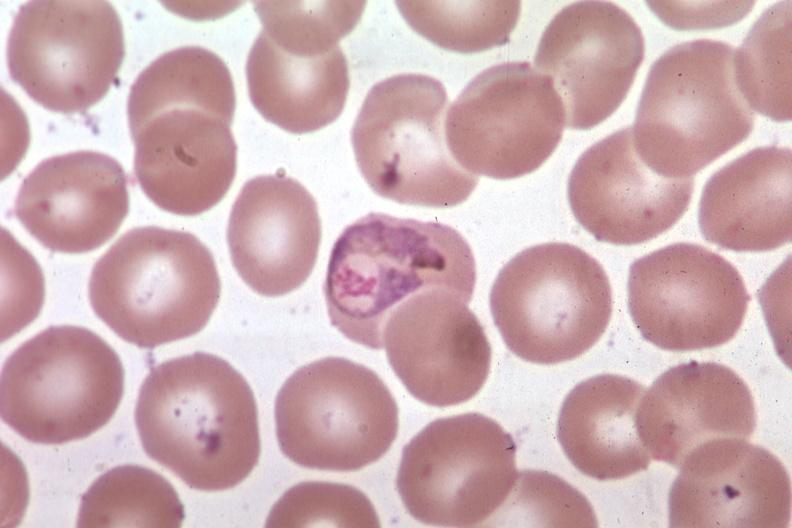s blood present?
Answer the question using a single word or phrase. Yes 